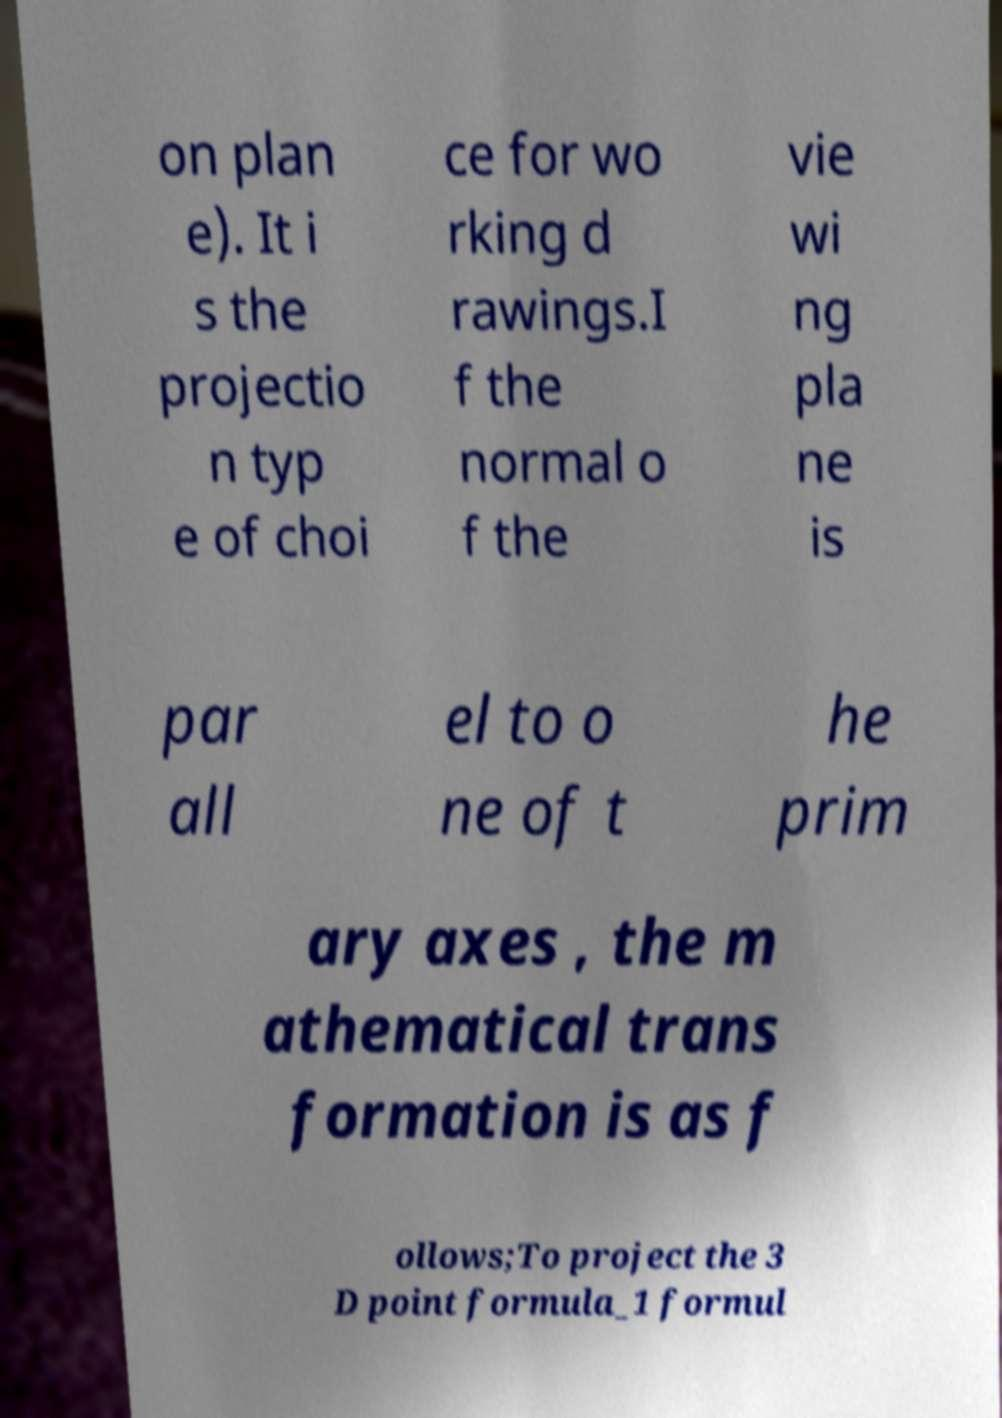What messages or text are displayed in this image? I need them in a readable, typed format. on plan e). It i s the projectio n typ e of choi ce for wo rking d rawings.I f the normal o f the vie wi ng pla ne is par all el to o ne of t he prim ary axes , the m athematical trans formation is as f ollows;To project the 3 D point formula_1 formul 